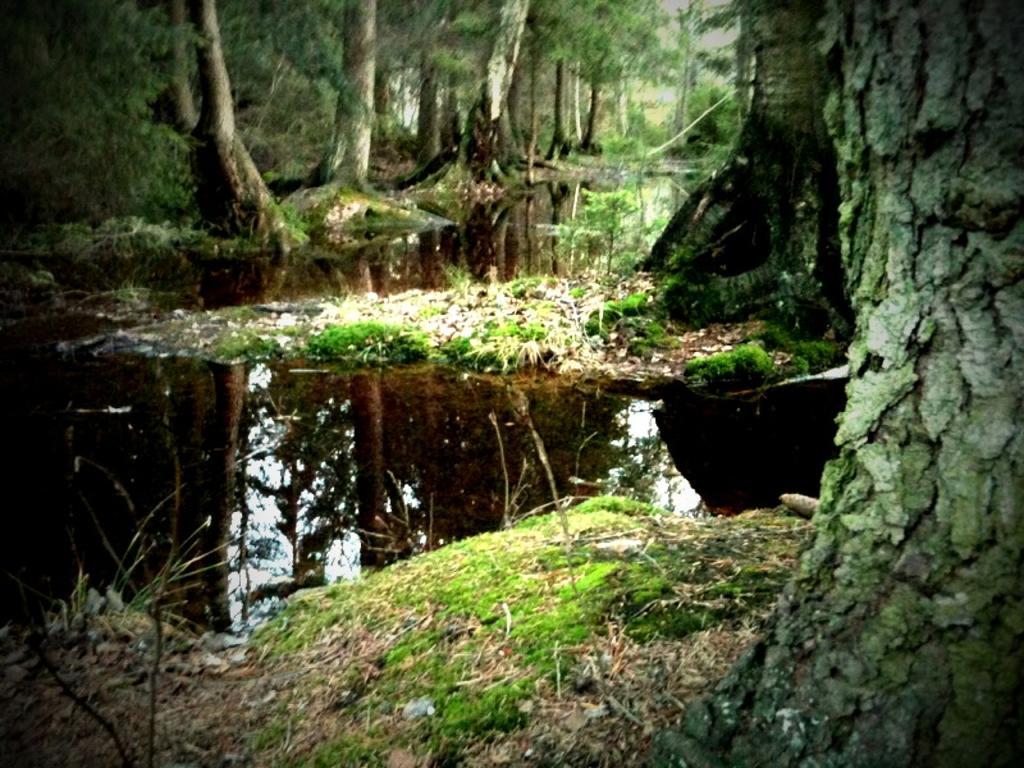How would you summarize this image in a sentence or two? In this image at the bottom there is one small pond and grass and trees, and in the background also there are a group of trees. 